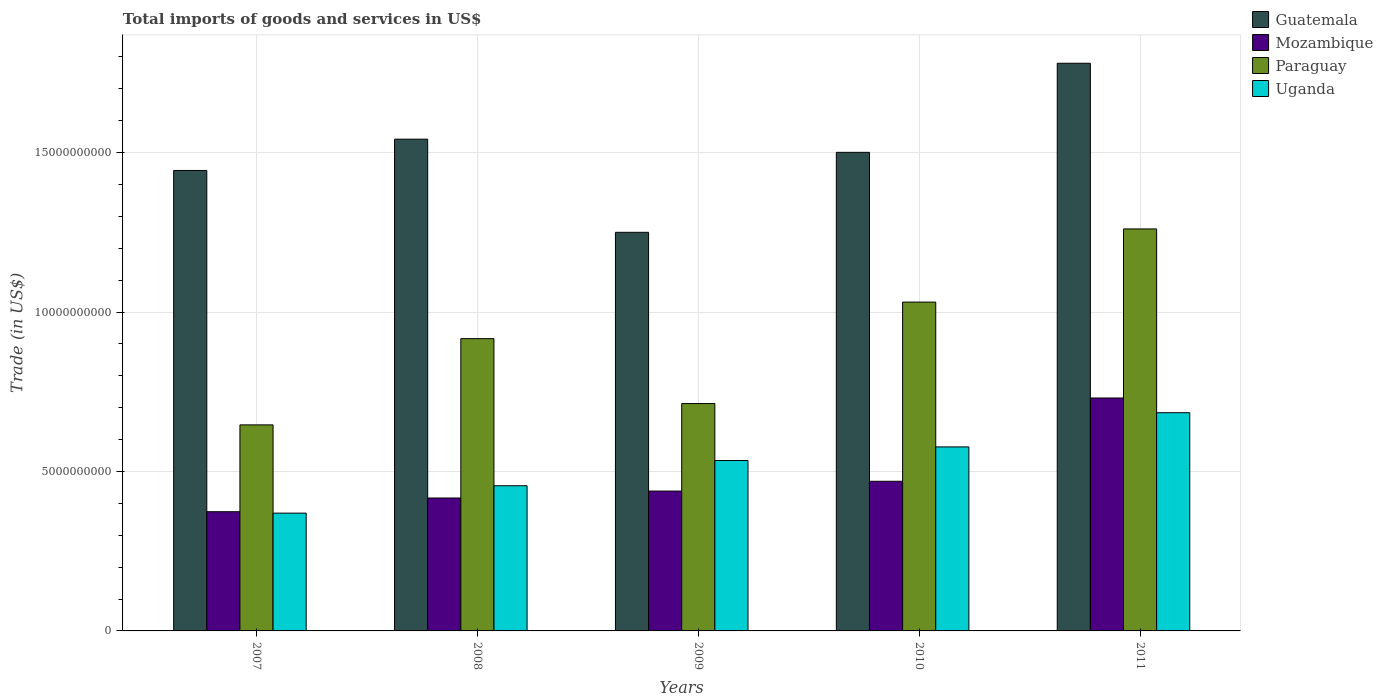How many different coloured bars are there?
Ensure brevity in your answer.  4. How many groups of bars are there?
Offer a very short reply. 5. Are the number of bars per tick equal to the number of legend labels?
Provide a succinct answer. Yes. Are the number of bars on each tick of the X-axis equal?
Provide a succinct answer. Yes. How many bars are there on the 2nd tick from the left?
Keep it short and to the point. 4. How many bars are there on the 2nd tick from the right?
Offer a very short reply. 4. What is the label of the 2nd group of bars from the left?
Your answer should be compact. 2008. In how many cases, is the number of bars for a given year not equal to the number of legend labels?
Offer a very short reply. 0. What is the total imports of goods and services in Guatemala in 2007?
Keep it short and to the point. 1.44e+1. Across all years, what is the maximum total imports of goods and services in Guatemala?
Your answer should be very brief. 1.78e+1. Across all years, what is the minimum total imports of goods and services in Paraguay?
Your response must be concise. 6.46e+09. What is the total total imports of goods and services in Paraguay in the graph?
Your answer should be very brief. 4.57e+1. What is the difference between the total imports of goods and services in Uganda in 2009 and that in 2010?
Offer a terse response. -4.27e+08. What is the difference between the total imports of goods and services in Guatemala in 2011 and the total imports of goods and services in Uganda in 2010?
Your response must be concise. 1.20e+1. What is the average total imports of goods and services in Mozambique per year?
Offer a very short reply. 4.86e+09. In the year 2007, what is the difference between the total imports of goods and services in Mozambique and total imports of goods and services in Uganda?
Ensure brevity in your answer.  4.42e+07. What is the ratio of the total imports of goods and services in Uganda in 2010 to that in 2011?
Offer a terse response. 0.84. What is the difference between the highest and the second highest total imports of goods and services in Uganda?
Provide a succinct answer. 1.07e+09. What is the difference between the highest and the lowest total imports of goods and services in Guatemala?
Give a very brief answer. 5.30e+09. In how many years, is the total imports of goods and services in Mozambique greater than the average total imports of goods and services in Mozambique taken over all years?
Provide a short and direct response. 1. Is the sum of the total imports of goods and services in Guatemala in 2007 and 2008 greater than the maximum total imports of goods and services in Uganda across all years?
Offer a terse response. Yes. Is it the case that in every year, the sum of the total imports of goods and services in Uganda and total imports of goods and services in Paraguay is greater than the sum of total imports of goods and services in Mozambique and total imports of goods and services in Guatemala?
Keep it short and to the point. No. What does the 1st bar from the left in 2007 represents?
Give a very brief answer. Guatemala. What does the 4th bar from the right in 2010 represents?
Provide a succinct answer. Guatemala. Is it the case that in every year, the sum of the total imports of goods and services in Paraguay and total imports of goods and services in Guatemala is greater than the total imports of goods and services in Uganda?
Provide a short and direct response. Yes. How many years are there in the graph?
Offer a terse response. 5. What is the difference between two consecutive major ticks on the Y-axis?
Ensure brevity in your answer.  5.00e+09. Does the graph contain grids?
Your answer should be compact. Yes. Where does the legend appear in the graph?
Offer a terse response. Top right. How many legend labels are there?
Your response must be concise. 4. How are the legend labels stacked?
Provide a succinct answer. Vertical. What is the title of the graph?
Your response must be concise. Total imports of goods and services in US$. What is the label or title of the Y-axis?
Offer a very short reply. Trade (in US$). What is the Trade (in US$) of Guatemala in 2007?
Give a very brief answer. 1.44e+1. What is the Trade (in US$) of Mozambique in 2007?
Offer a terse response. 3.74e+09. What is the Trade (in US$) in Paraguay in 2007?
Keep it short and to the point. 6.46e+09. What is the Trade (in US$) in Uganda in 2007?
Your answer should be compact. 3.69e+09. What is the Trade (in US$) of Guatemala in 2008?
Offer a very short reply. 1.54e+1. What is the Trade (in US$) in Mozambique in 2008?
Make the answer very short. 4.17e+09. What is the Trade (in US$) in Paraguay in 2008?
Your answer should be compact. 9.17e+09. What is the Trade (in US$) in Uganda in 2008?
Provide a succinct answer. 4.55e+09. What is the Trade (in US$) of Guatemala in 2009?
Offer a terse response. 1.25e+1. What is the Trade (in US$) in Mozambique in 2009?
Provide a succinct answer. 4.39e+09. What is the Trade (in US$) of Paraguay in 2009?
Your answer should be very brief. 7.13e+09. What is the Trade (in US$) of Uganda in 2009?
Keep it short and to the point. 5.34e+09. What is the Trade (in US$) of Guatemala in 2010?
Offer a very short reply. 1.50e+1. What is the Trade (in US$) in Mozambique in 2010?
Offer a terse response. 4.69e+09. What is the Trade (in US$) in Paraguay in 2010?
Make the answer very short. 1.03e+1. What is the Trade (in US$) of Uganda in 2010?
Offer a terse response. 5.77e+09. What is the Trade (in US$) in Guatemala in 2011?
Provide a short and direct response. 1.78e+1. What is the Trade (in US$) of Mozambique in 2011?
Provide a succinct answer. 7.31e+09. What is the Trade (in US$) in Paraguay in 2011?
Your answer should be compact. 1.26e+1. What is the Trade (in US$) of Uganda in 2011?
Provide a short and direct response. 6.84e+09. Across all years, what is the maximum Trade (in US$) of Guatemala?
Ensure brevity in your answer.  1.78e+1. Across all years, what is the maximum Trade (in US$) in Mozambique?
Ensure brevity in your answer.  7.31e+09. Across all years, what is the maximum Trade (in US$) in Paraguay?
Make the answer very short. 1.26e+1. Across all years, what is the maximum Trade (in US$) in Uganda?
Keep it short and to the point. 6.84e+09. Across all years, what is the minimum Trade (in US$) of Guatemala?
Give a very brief answer. 1.25e+1. Across all years, what is the minimum Trade (in US$) of Mozambique?
Offer a terse response. 3.74e+09. Across all years, what is the minimum Trade (in US$) of Paraguay?
Keep it short and to the point. 6.46e+09. Across all years, what is the minimum Trade (in US$) in Uganda?
Your answer should be compact. 3.69e+09. What is the total Trade (in US$) in Guatemala in the graph?
Make the answer very short. 7.52e+1. What is the total Trade (in US$) in Mozambique in the graph?
Provide a short and direct response. 2.43e+1. What is the total Trade (in US$) of Paraguay in the graph?
Your response must be concise. 4.57e+1. What is the total Trade (in US$) in Uganda in the graph?
Ensure brevity in your answer.  2.62e+1. What is the difference between the Trade (in US$) of Guatemala in 2007 and that in 2008?
Keep it short and to the point. -9.81e+08. What is the difference between the Trade (in US$) in Mozambique in 2007 and that in 2008?
Ensure brevity in your answer.  -4.30e+08. What is the difference between the Trade (in US$) in Paraguay in 2007 and that in 2008?
Give a very brief answer. -2.70e+09. What is the difference between the Trade (in US$) of Uganda in 2007 and that in 2008?
Provide a succinct answer. -8.59e+08. What is the difference between the Trade (in US$) in Guatemala in 2007 and that in 2009?
Give a very brief answer. 1.94e+09. What is the difference between the Trade (in US$) in Mozambique in 2007 and that in 2009?
Keep it short and to the point. -6.48e+08. What is the difference between the Trade (in US$) of Paraguay in 2007 and that in 2009?
Provide a short and direct response. -6.68e+08. What is the difference between the Trade (in US$) of Uganda in 2007 and that in 2009?
Offer a terse response. -1.65e+09. What is the difference between the Trade (in US$) in Guatemala in 2007 and that in 2010?
Your answer should be compact. -5.68e+08. What is the difference between the Trade (in US$) in Mozambique in 2007 and that in 2010?
Offer a terse response. -9.55e+08. What is the difference between the Trade (in US$) of Paraguay in 2007 and that in 2010?
Offer a very short reply. -3.85e+09. What is the difference between the Trade (in US$) of Uganda in 2007 and that in 2010?
Provide a short and direct response. -2.08e+09. What is the difference between the Trade (in US$) in Guatemala in 2007 and that in 2011?
Ensure brevity in your answer.  -3.36e+09. What is the difference between the Trade (in US$) in Mozambique in 2007 and that in 2011?
Provide a succinct answer. -3.57e+09. What is the difference between the Trade (in US$) in Paraguay in 2007 and that in 2011?
Your answer should be compact. -6.15e+09. What is the difference between the Trade (in US$) of Uganda in 2007 and that in 2011?
Keep it short and to the point. -3.15e+09. What is the difference between the Trade (in US$) of Guatemala in 2008 and that in 2009?
Your answer should be very brief. 2.92e+09. What is the difference between the Trade (in US$) in Mozambique in 2008 and that in 2009?
Your answer should be very brief. -2.17e+08. What is the difference between the Trade (in US$) in Paraguay in 2008 and that in 2009?
Offer a terse response. 2.04e+09. What is the difference between the Trade (in US$) in Uganda in 2008 and that in 2009?
Ensure brevity in your answer.  -7.90e+08. What is the difference between the Trade (in US$) of Guatemala in 2008 and that in 2010?
Offer a very short reply. 4.13e+08. What is the difference between the Trade (in US$) of Mozambique in 2008 and that in 2010?
Provide a succinct answer. -5.25e+08. What is the difference between the Trade (in US$) of Paraguay in 2008 and that in 2010?
Provide a short and direct response. -1.15e+09. What is the difference between the Trade (in US$) of Uganda in 2008 and that in 2010?
Ensure brevity in your answer.  -1.22e+09. What is the difference between the Trade (in US$) of Guatemala in 2008 and that in 2011?
Offer a very short reply. -2.38e+09. What is the difference between the Trade (in US$) in Mozambique in 2008 and that in 2011?
Provide a succinct answer. -3.14e+09. What is the difference between the Trade (in US$) of Paraguay in 2008 and that in 2011?
Provide a short and direct response. -3.44e+09. What is the difference between the Trade (in US$) in Uganda in 2008 and that in 2011?
Make the answer very short. -2.29e+09. What is the difference between the Trade (in US$) in Guatemala in 2009 and that in 2010?
Your answer should be very brief. -2.51e+09. What is the difference between the Trade (in US$) in Mozambique in 2009 and that in 2010?
Your answer should be compact. -3.07e+08. What is the difference between the Trade (in US$) in Paraguay in 2009 and that in 2010?
Give a very brief answer. -3.18e+09. What is the difference between the Trade (in US$) of Uganda in 2009 and that in 2010?
Your answer should be very brief. -4.27e+08. What is the difference between the Trade (in US$) of Guatemala in 2009 and that in 2011?
Offer a very short reply. -5.30e+09. What is the difference between the Trade (in US$) of Mozambique in 2009 and that in 2011?
Give a very brief answer. -2.92e+09. What is the difference between the Trade (in US$) in Paraguay in 2009 and that in 2011?
Your response must be concise. -5.48e+09. What is the difference between the Trade (in US$) in Uganda in 2009 and that in 2011?
Your answer should be very brief. -1.50e+09. What is the difference between the Trade (in US$) of Guatemala in 2010 and that in 2011?
Ensure brevity in your answer.  -2.79e+09. What is the difference between the Trade (in US$) in Mozambique in 2010 and that in 2011?
Your response must be concise. -2.61e+09. What is the difference between the Trade (in US$) of Paraguay in 2010 and that in 2011?
Provide a succinct answer. -2.29e+09. What is the difference between the Trade (in US$) in Uganda in 2010 and that in 2011?
Offer a terse response. -1.07e+09. What is the difference between the Trade (in US$) of Guatemala in 2007 and the Trade (in US$) of Mozambique in 2008?
Keep it short and to the point. 1.03e+1. What is the difference between the Trade (in US$) in Guatemala in 2007 and the Trade (in US$) in Paraguay in 2008?
Offer a very short reply. 5.27e+09. What is the difference between the Trade (in US$) of Guatemala in 2007 and the Trade (in US$) of Uganda in 2008?
Your response must be concise. 9.89e+09. What is the difference between the Trade (in US$) of Mozambique in 2007 and the Trade (in US$) of Paraguay in 2008?
Give a very brief answer. -5.43e+09. What is the difference between the Trade (in US$) of Mozambique in 2007 and the Trade (in US$) of Uganda in 2008?
Provide a short and direct response. -8.15e+08. What is the difference between the Trade (in US$) of Paraguay in 2007 and the Trade (in US$) of Uganda in 2008?
Make the answer very short. 1.91e+09. What is the difference between the Trade (in US$) of Guatemala in 2007 and the Trade (in US$) of Mozambique in 2009?
Provide a succinct answer. 1.01e+1. What is the difference between the Trade (in US$) of Guatemala in 2007 and the Trade (in US$) of Paraguay in 2009?
Provide a succinct answer. 7.31e+09. What is the difference between the Trade (in US$) of Guatemala in 2007 and the Trade (in US$) of Uganda in 2009?
Your response must be concise. 9.10e+09. What is the difference between the Trade (in US$) in Mozambique in 2007 and the Trade (in US$) in Paraguay in 2009?
Ensure brevity in your answer.  -3.39e+09. What is the difference between the Trade (in US$) of Mozambique in 2007 and the Trade (in US$) of Uganda in 2009?
Provide a succinct answer. -1.60e+09. What is the difference between the Trade (in US$) of Paraguay in 2007 and the Trade (in US$) of Uganda in 2009?
Your answer should be compact. 1.12e+09. What is the difference between the Trade (in US$) in Guatemala in 2007 and the Trade (in US$) in Mozambique in 2010?
Offer a terse response. 9.75e+09. What is the difference between the Trade (in US$) of Guatemala in 2007 and the Trade (in US$) of Paraguay in 2010?
Offer a terse response. 4.13e+09. What is the difference between the Trade (in US$) of Guatemala in 2007 and the Trade (in US$) of Uganda in 2010?
Make the answer very short. 8.67e+09. What is the difference between the Trade (in US$) of Mozambique in 2007 and the Trade (in US$) of Paraguay in 2010?
Provide a short and direct response. -6.57e+09. What is the difference between the Trade (in US$) in Mozambique in 2007 and the Trade (in US$) in Uganda in 2010?
Your response must be concise. -2.03e+09. What is the difference between the Trade (in US$) of Paraguay in 2007 and the Trade (in US$) of Uganda in 2010?
Give a very brief answer. 6.91e+08. What is the difference between the Trade (in US$) of Guatemala in 2007 and the Trade (in US$) of Mozambique in 2011?
Offer a terse response. 7.14e+09. What is the difference between the Trade (in US$) of Guatemala in 2007 and the Trade (in US$) of Paraguay in 2011?
Offer a terse response. 1.83e+09. What is the difference between the Trade (in US$) in Guatemala in 2007 and the Trade (in US$) in Uganda in 2011?
Give a very brief answer. 7.60e+09. What is the difference between the Trade (in US$) of Mozambique in 2007 and the Trade (in US$) of Paraguay in 2011?
Ensure brevity in your answer.  -8.87e+09. What is the difference between the Trade (in US$) of Mozambique in 2007 and the Trade (in US$) of Uganda in 2011?
Give a very brief answer. -3.11e+09. What is the difference between the Trade (in US$) of Paraguay in 2007 and the Trade (in US$) of Uganda in 2011?
Ensure brevity in your answer.  -3.82e+08. What is the difference between the Trade (in US$) in Guatemala in 2008 and the Trade (in US$) in Mozambique in 2009?
Give a very brief answer. 1.10e+1. What is the difference between the Trade (in US$) of Guatemala in 2008 and the Trade (in US$) of Paraguay in 2009?
Your answer should be compact. 8.29e+09. What is the difference between the Trade (in US$) of Guatemala in 2008 and the Trade (in US$) of Uganda in 2009?
Your answer should be very brief. 1.01e+1. What is the difference between the Trade (in US$) of Mozambique in 2008 and the Trade (in US$) of Paraguay in 2009?
Provide a succinct answer. -2.96e+09. What is the difference between the Trade (in US$) in Mozambique in 2008 and the Trade (in US$) in Uganda in 2009?
Ensure brevity in your answer.  -1.17e+09. What is the difference between the Trade (in US$) of Paraguay in 2008 and the Trade (in US$) of Uganda in 2009?
Ensure brevity in your answer.  3.82e+09. What is the difference between the Trade (in US$) in Guatemala in 2008 and the Trade (in US$) in Mozambique in 2010?
Provide a short and direct response. 1.07e+1. What is the difference between the Trade (in US$) of Guatemala in 2008 and the Trade (in US$) of Paraguay in 2010?
Provide a succinct answer. 5.11e+09. What is the difference between the Trade (in US$) in Guatemala in 2008 and the Trade (in US$) in Uganda in 2010?
Provide a short and direct response. 9.65e+09. What is the difference between the Trade (in US$) in Mozambique in 2008 and the Trade (in US$) in Paraguay in 2010?
Offer a terse response. -6.14e+09. What is the difference between the Trade (in US$) in Mozambique in 2008 and the Trade (in US$) in Uganda in 2010?
Keep it short and to the point. -1.60e+09. What is the difference between the Trade (in US$) of Paraguay in 2008 and the Trade (in US$) of Uganda in 2010?
Your answer should be compact. 3.40e+09. What is the difference between the Trade (in US$) in Guatemala in 2008 and the Trade (in US$) in Mozambique in 2011?
Make the answer very short. 8.12e+09. What is the difference between the Trade (in US$) of Guatemala in 2008 and the Trade (in US$) of Paraguay in 2011?
Offer a terse response. 2.81e+09. What is the difference between the Trade (in US$) of Guatemala in 2008 and the Trade (in US$) of Uganda in 2011?
Your answer should be compact. 8.58e+09. What is the difference between the Trade (in US$) in Mozambique in 2008 and the Trade (in US$) in Paraguay in 2011?
Offer a terse response. -8.44e+09. What is the difference between the Trade (in US$) of Mozambique in 2008 and the Trade (in US$) of Uganda in 2011?
Make the answer very short. -2.67e+09. What is the difference between the Trade (in US$) of Paraguay in 2008 and the Trade (in US$) of Uganda in 2011?
Your answer should be very brief. 2.32e+09. What is the difference between the Trade (in US$) in Guatemala in 2009 and the Trade (in US$) in Mozambique in 2010?
Your response must be concise. 7.81e+09. What is the difference between the Trade (in US$) in Guatemala in 2009 and the Trade (in US$) in Paraguay in 2010?
Keep it short and to the point. 2.19e+09. What is the difference between the Trade (in US$) of Guatemala in 2009 and the Trade (in US$) of Uganda in 2010?
Your answer should be very brief. 6.73e+09. What is the difference between the Trade (in US$) in Mozambique in 2009 and the Trade (in US$) in Paraguay in 2010?
Provide a succinct answer. -5.93e+09. What is the difference between the Trade (in US$) of Mozambique in 2009 and the Trade (in US$) of Uganda in 2010?
Keep it short and to the point. -1.38e+09. What is the difference between the Trade (in US$) of Paraguay in 2009 and the Trade (in US$) of Uganda in 2010?
Offer a very short reply. 1.36e+09. What is the difference between the Trade (in US$) in Guatemala in 2009 and the Trade (in US$) in Mozambique in 2011?
Your response must be concise. 5.20e+09. What is the difference between the Trade (in US$) in Guatemala in 2009 and the Trade (in US$) in Paraguay in 2011?
Your answer should be very brief. -1.06e+08. What is the difference between the Trade (in US$) in Guatemala in 2009 and the Trade (in US$) in Uganda in 2011?
Ensure brevity in your answer.  5.66e+09. What is the difference between the Trade (in US$) in Mozambique in 2009 and the Trade (in US$) in Paraguay in 2011?
Offer a terse response. -8.22e+09. What is the difference between the Trade (in US$) in Mozambique in 2009 and the Trade (in US$) in Uganda in 2011?
Provide a succinct answer. -2.46e+09. What is the difference between the Trade (in US$) of Paraguay in 2009 and the Trade (in US$) of Uganda in 2011?
Your response must be concise. 2.86e+08. What is the difference between the Trade (in US$) of Guatemala in 2010 and the Trade (in US$) of Mozambique in 2011?
Your response must be concise. 7.70e+09. What is the difference between the Trade (in US$) of Guatemala in 2010 and the Trade (in US$) of Paraguay in 2011?
Your answer should be compact. 2.40e+09. What is the difference between the Trade (in US$) in Guatemala in 2010 and the Trade (in US$) in Uganda in 2011?
Offer a very short reply. 8.17e+09. What is the difference between the Trade (in US$) of Mozambique in 2010 and the Trade (in US$) of Paraguay in 2011?
Keep it short and to the point. -7.91e+09. What is the difference between the Trade (in US$) in Mozambique in 2010 and the Trade (in US$) in Uganda in 2011?
Your answer should be compact. -2.15e+09. What is the difference between the Trade (in US$) of Paraguay in 2010 and the Trade (in US$) of Uganda in 2011?
Provide a succinct answer. 3.47e+09. What is the average Trade (in US$) of Guatemala per year?
Your answer should be very brief. 1.50e+1. What is the average Trade (in US$) of Mozambique per year?
Give a very brief answer. 4.86e+09. What is the average Trade (in US$) in Paraguay per year?
Your answer should be very brief. 9.14e+09. What is the average Trade (in US$) in Uganda per year?
Keep it short and to the point. 5.24e+09. In the year 2007, what is the difference between the Trade (in US$) of Guatemala and Trade (in US$) of Mozambique?
Your response must be concise. 1.07e+1. In the year 2007, what is the difference between the Trade (in US$) in Guatemala and Trade (in US$) in Paraguay?
Your response must be concise. 7.98e+09. In the year 2007, what is the difference between the Trade (in US$) of Guatemala and Trade (in US$) of Uganda?
Your answer should be very brief. 1.07e+1. In the year 2007, what is the difference between the Trade (in US$) of Mozambique and Trade (in US$) of Paraguay?
Offer a terse response. -2.72e+09. In the year 2007, what is the difference between the Trade (in US$) of Mozambique and Trade (in US$) of Uganda?
Keep it short and to the point. 4.42e+07. In the year 2007, what is the difference between the Trade (in US$) in Paraguay and Trade (in US$) in Uganda?
Your response must be concise. 2.77e+09. In the year 2008, what is the difference between the Trade (in US$) of Guatemala and Trade (in US$) of Mozambique?
Your answer should be very brief. 1.13e+1. In the year 2008, what is the difference between the Trade (in US$) in Guatemala and Trade (in US$) in Paraguay?
Offer a terse response. 6.26e+09. In the year 2008, what is the difference between the Trade (in US$) of Guatemala and Trade (in US$) of Uganda?
Make the answer very short. 1.09e+1. In the year 2008, what is the difference between the Trade (in US$) in Mozambique and Trade (in US$) in Paraguay?
Offer a terse response. -5.00e+09. In the year 2008, what is the difference between the Trade (in US$) of Mozambique and Trade (in US$) of Uganda?
Keep it short and to the point. -3.85e+08. In the year 2008, what is the difference between the Trade (in US$) in Paraguay and Trade (in US$) in Uganda?
Give a very brief answer. 4.61e+09. In the year 2009, what is the difference between the Trade (in US$) in Guatemala and Trade (in US$) in Mozambique?
Provide a short and direct response. 8.12e+09. In the year 2009, what is the difference between the Trade (in US$) in Guatemala and Trade (in US$) in Paraguay?
Your answer should be very brief. 5.37e+09. In the year 2009, what is the difference between the Trade (in US$) in Guatemala and Trade (in US$) in Uganda?
Your answer should be very brief. 7.16e+09. In the year 2009, what is the difference between the Trade (in US$) of Mozambique and Trade (in US$) of Paraguay?
Offer a very short reply. -2.74e+09. In the year 2009, what is the difference between the Trade (in US$) of Mozambique and Trade (in US$) of Uganda?
Your answer should be very brief. -9.57e+08. In the year 2009, what is the difference between the Trade (in US$) of Paraguay and Trade (in US$) of Uganda?
Keep it short and to the point. 1.79e+09. In the year 2010, what is the difference between the Trade (in US$) of Guatemala and Trade (in US$) of Mozambique?
Your answer should be compact. 1.03e+1. In the year 2010, what is the difference between the Trade (in US$) of Guatemala and Trade (in US$) of Paraguay?
Provide a succinct answer. 4.70e+09. In the year 2010, what is the difference between the Trade (in US$) of Guatemala and Trade (in US$) of Uganda?
Keep it short and to the point. 9.24e+09. In the year 2010, what is the difference between the Trade (in US$) in Mozambique and Trade (in US$) in Paraguay?
Your response must be concise. -5.62e+09. In the year 2010, what is the difference between the Trade (in US$) of Mozambique and Trade (in US$) of Uganda?
Your answer should be very brief. -1.08e+09. In the year 2010, what is the difference between the Trade (in US$) of Paraguay and Trade (in US$) of Uganda?
Your answer should be compact. 4.54e+09. In the year 2011, what is the difference between the Trade (in US$) of Guatemala and Trade (in US$) of Mozambique?
Your answer should be compact. 1.05e+1. In the year 2011, what is the difference between the Trade (in US$) of Guatemala and Trade (in US$) of Paraguay?
Give a very brief answer. 5.20e+09. In the year 2011, what is the difference between the Trade (in US$) in Guatemala and Trade (in US$) in Uganda?
Give a very brief answer. 1.10e+1. In the year 2011, what is the difference between the Trade (in US$) of Mozambique and Trade (in US$) of Paraguay?
Ensure brevity in your answer.  -5.30e+09. In the year 2011, what is the difference between the Trade (in US$) of Mozambique and Trade (in US$) of Uganda?
Your answer should be compact. 4.61e+08. In the year 2011, what is the difference between the Trade (in US$) of Paraguay and Trade (in US$) of Uganda?
Your response must be concise. 5.76e+09. What is the ratio of the Trade (in US$) in Guatemala in 2007 to that in 2008?
Provide a succinct answer. 0.94. What is the ratio of the Trade (in US$) in Mozambique in 2007 to that in 2008?
Provide a short and direct response. 0.9. What is the ratio of the Trade (in US$) in Paraguay in 2007 to that in 2008?
Offer a terse response. 0.7. What is the ratio of the Trade (in US$) in Uganda in 2007 to that in 2008?
Your answer should be very brief. 0.81. What is the ratio of the Trade (in US$) in Guatemala in 2007 to that in 2009?
Offer a terse response. 1.16. What is the ratio of the Trade (in US$) in Mozambique in 2007 to that in 2009?
Your answer should be very brief. 0.85. What is the ratio of the Trade (in US$) in Paraguay in 2007 to that in 2009?
Offer a very short reply. 0.91. What is the ratio of the Trade (in US$) in Uganda in 2007 to that in 2009?
Give a very brief answer. 0.69. What is the ratio of the Trade (in US$) in Guatemala in 2007 to that in 2010?
Your answer should be compact. 0.96. What is the ratio of the Trade (in US$) in Mozambique in 2007 to that in 2010?
Provide a short and direct response. 0.8. What is the ratio of the Trade (in US$) in Paraguay in 2007 to that in 2010?
Provide a short and direct response. 0.63. What is the ratio of the Trade (in US$) in Uganda in 2007 to that in 2010?
Offer a terse response. 0.64. What is the ratio of the Trade (in US$) of Guatemala in 2007 to that in 2011?
Give a very brief answer. 0.81. What is the ratio of the Trade (in US$) of Mozambique in 2007 to that in 2011?
Give a very brief answer. 0.51. What is the ratio of the Trade (in US$) of Paraguay in 2007 to that in 2011?
Your answer should be compact. 0.51. What is the ratio of the Trade (in US$) in Uganda in 2007 to that in 2011?
Your answer should be compact. 0.54. What is the ratio of the Trade (in US$) in Guatemala in 2008 to that in 2009?
Provide a short and direct response. 1.23. What is the ratio of the Trade (in US$) in Mozambique in 2008 to that in 2009?
Provide a succinct answer. 0.95. What is the ratio of the Trade (in US$) in Paraguay in 2008 to that in 2009?
Your response must be concise. 1.29. What is the ratio of the Trade (in US$) in Uganda in 2008 to that in 2009?
Provide a succinct answer. 0.85. What is the ratio of the Trade (in US$) of Guatemala in 2008 to that in 2010?
Make the answer very short. 1.03. What is the ratio of the Trade (in US$) in Mozambique in 2008 to that in 2010?
Make the answer very short. 0.89. What is the ratio of the Trade (in US$) of Paraguay in 2008 to that in 2010?
Your response must be concise. 0.89. What is the ratio of the Trade (in US$) in Uganda in 2008 to that in 2010?
Keep it short and to the point. 0.79. What is the ratio of the Trade (in US$) of Guatemala in 2008 to that in 2011?
Offer a terse response. 0.87. What is the ratio of the Trade (in US$) of Mozambique in 2008 to that in 2011?
Give a very brief answer. 0.57. What is the ratio of the Trade (in US$) of Paraguay in 2008 to that in 2011?
Offer a very short reply. 0.73. What is the ratio of the Trade (in US$) of Uganda in 2008 to that in 2011?
Your answer should be compact. 0.67. What is the ratio of the Trade (in US$) of Guatemala in 2009 to that in 2010?
Make the answer very short. 0.83. What is the ratio of the Trade (in US$) of Mozambique in 2009 to that in 2010?
Make the answer very short. 0.93. What is the ratio of the Trade (in US$) of Paraguay in 2009 to that in 2010?
Offer a very short reply. 0.69. What is the ratio of the Trade (in US$) of Uganda in 2009 to that in 2010?
Provide a short and direct response. 0.93. What is the ratio of the Trade (in US$) in Guatemala in 2009 to that in 2011?
Provide a succinct answer. 0.7. What is the ratio of the Trade (in US$) in Mozambique in 2009 to that in 2011?
Offer a very short reply. 0.6. What is the ratio of the Trade (in US$) in Paraguay in 2009 to that in 2011?
Give a very brief answer. 0.57. What is the ratio of the Trade (in US$) in Uganda in 2009 to that in 2011?
Give a very brief answer. 0.78. What is the ratio of the Trade (in US$) of Guatemala in 2010 to that in 2011?
Ensure brevity in your answer.  0.84. What is the ratio of the Trade (in US$) of Mozambique in 2010 to that in 2011?
Make the answer very short. 0.64. What is the ratio of the Trade (in US$) of Paraguay in 2010 to that in 2011?
Ensure brevity in your answer.  0.82. What is the ratio of the Trade (in US$) in Uganda in 2010 to that in 2011?
Keep it short and to the point. 0.84. What is the difference between the highest and the second highest Trade (in US$) of Guatemala?
Your response must be concise. 2.38e+09. What is the difference between the highest and the second highest Trade (in US$) in Mozambique?
Offer a very short reply. 2.61e+09. What is the difference between the highest and the second highest Trade (in US$) of Paraguay?
Provide a short and direct response. 2.29e+09. What is the difference between the highest and the second highest Trade (in US$) of Uganda?
Offer a very short reply. 1.07e+09. What is the difference between the highest and the lowest Trade (in US$) in Guatemala?
Your response must be concise. 5.30e+09. What is the difference between the highest and the lowest Trade (in US$) of Mozambique?
Keep it short and to the point. 3.57e+09. What is the difference between the highest and the lowest Trade (in US$) of Paraguay?
Offer a terse response. 6.15e+09. What is the difference between the highest and the lowest Trade (in US$) of Uganda?
Provide a succinct answer. 3.15e+09. 